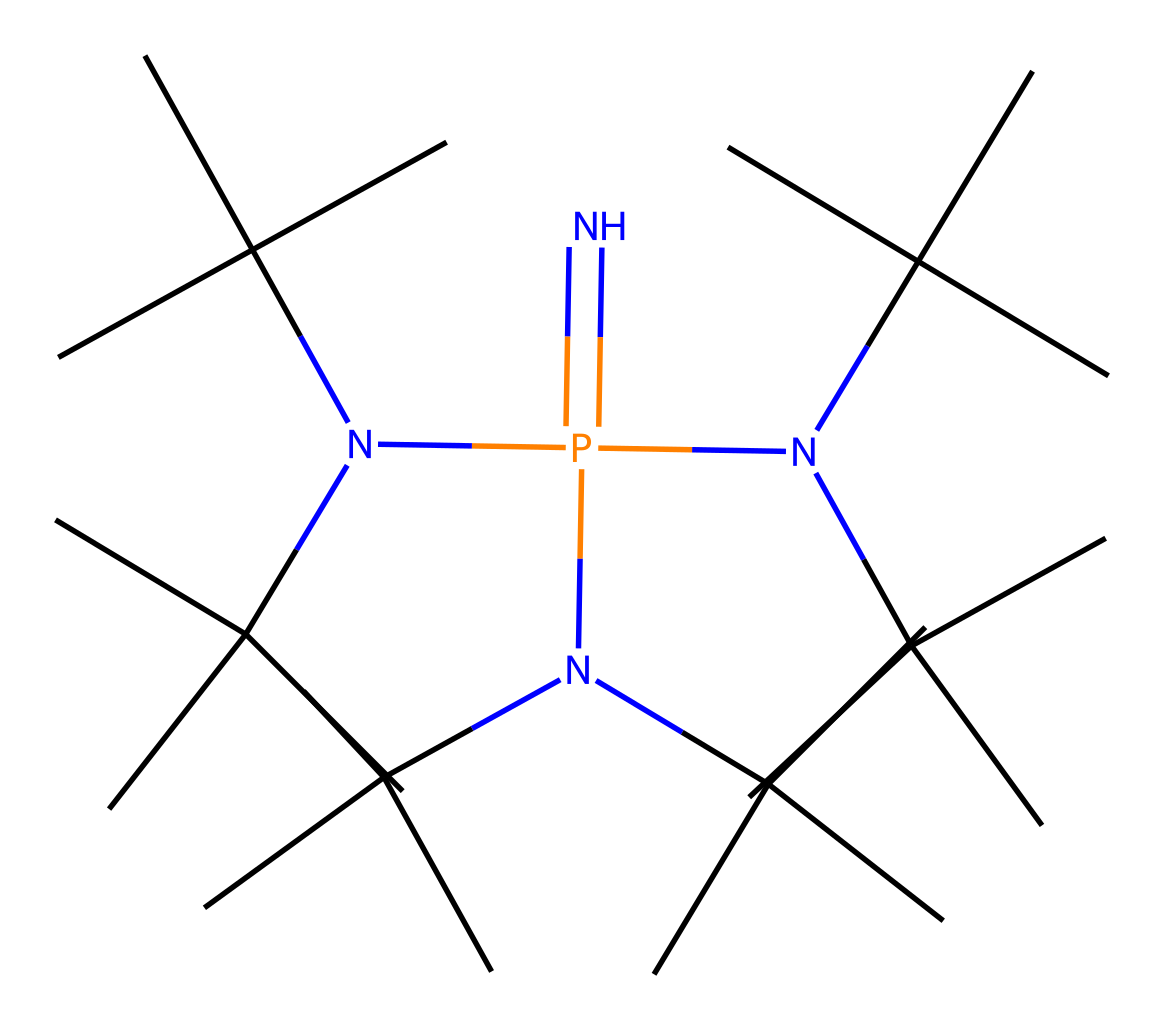What is the central atom in this molecule? The molecule's structure shows that phosphorus (P) is the main atom around which the rest of the structure is organized; it is clearly indicated as a central atom in the SMILES representation.
Answer: phosphorus How many nitrogen atoms are present in the structure? By analyzing the SMILES representation, we can see that there are four nitrogen (N) atoms attached to the central phosphorus atom, indicating a total of four nitrogens in the entire molecule.
Answer: four What type of bonding is predominantly present in this molecule? The presence of multiple N-P bonds and carbon chains suggests that covalent bonding is the predominant form of bonding in this phosphazene base structure.
Answer: covalent How many isopropyl groups are attached to the nitrogen atoms? Each nitrogen atom contains an isopropyl group, and since there are three nitrogen atoms where isopropyl groups are observed directly in the structure, that totals to six isopropyl groups in the entire molecule.
Answer: six What kind of chemical is this structure classified as? Due to the high number of nitrogen atoms linked to phosphorus, specifically forming phosphazene, this compound can be classified as a phosphazene base, which is known to be a superbases in organic chemistry.
Answer: phosphazene base What key feature makes this compound a superbase? The presence of multiple nitrogen atoms in its structure enhances its basicity; hence, the combined nitrogen functionalities with phosphorus in this particular structural arrangement contribute to its classification as a superbase.
Answer: basicity 